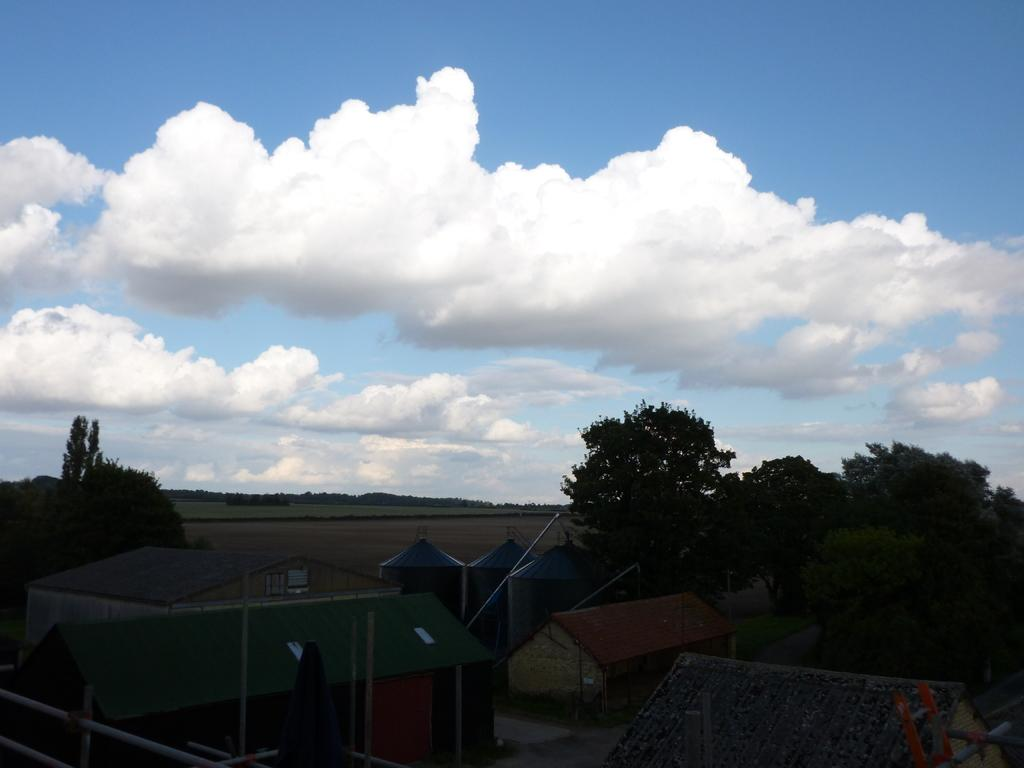What type of natural vegetation can be seen in the image? There are trees in the image. What type of man-made structures are present in the image? There are houses in the image. Can you describe any other objects visible in the image? There are other objects in the image, but their specific nature is not mentioned in the provided facts. What is visible in the background of the image? The sky is visible in the background of the image. How many bottles of water are visible in the image? There is no mention of bottles of water in the provided facts, so it cannot be determined from the image. 